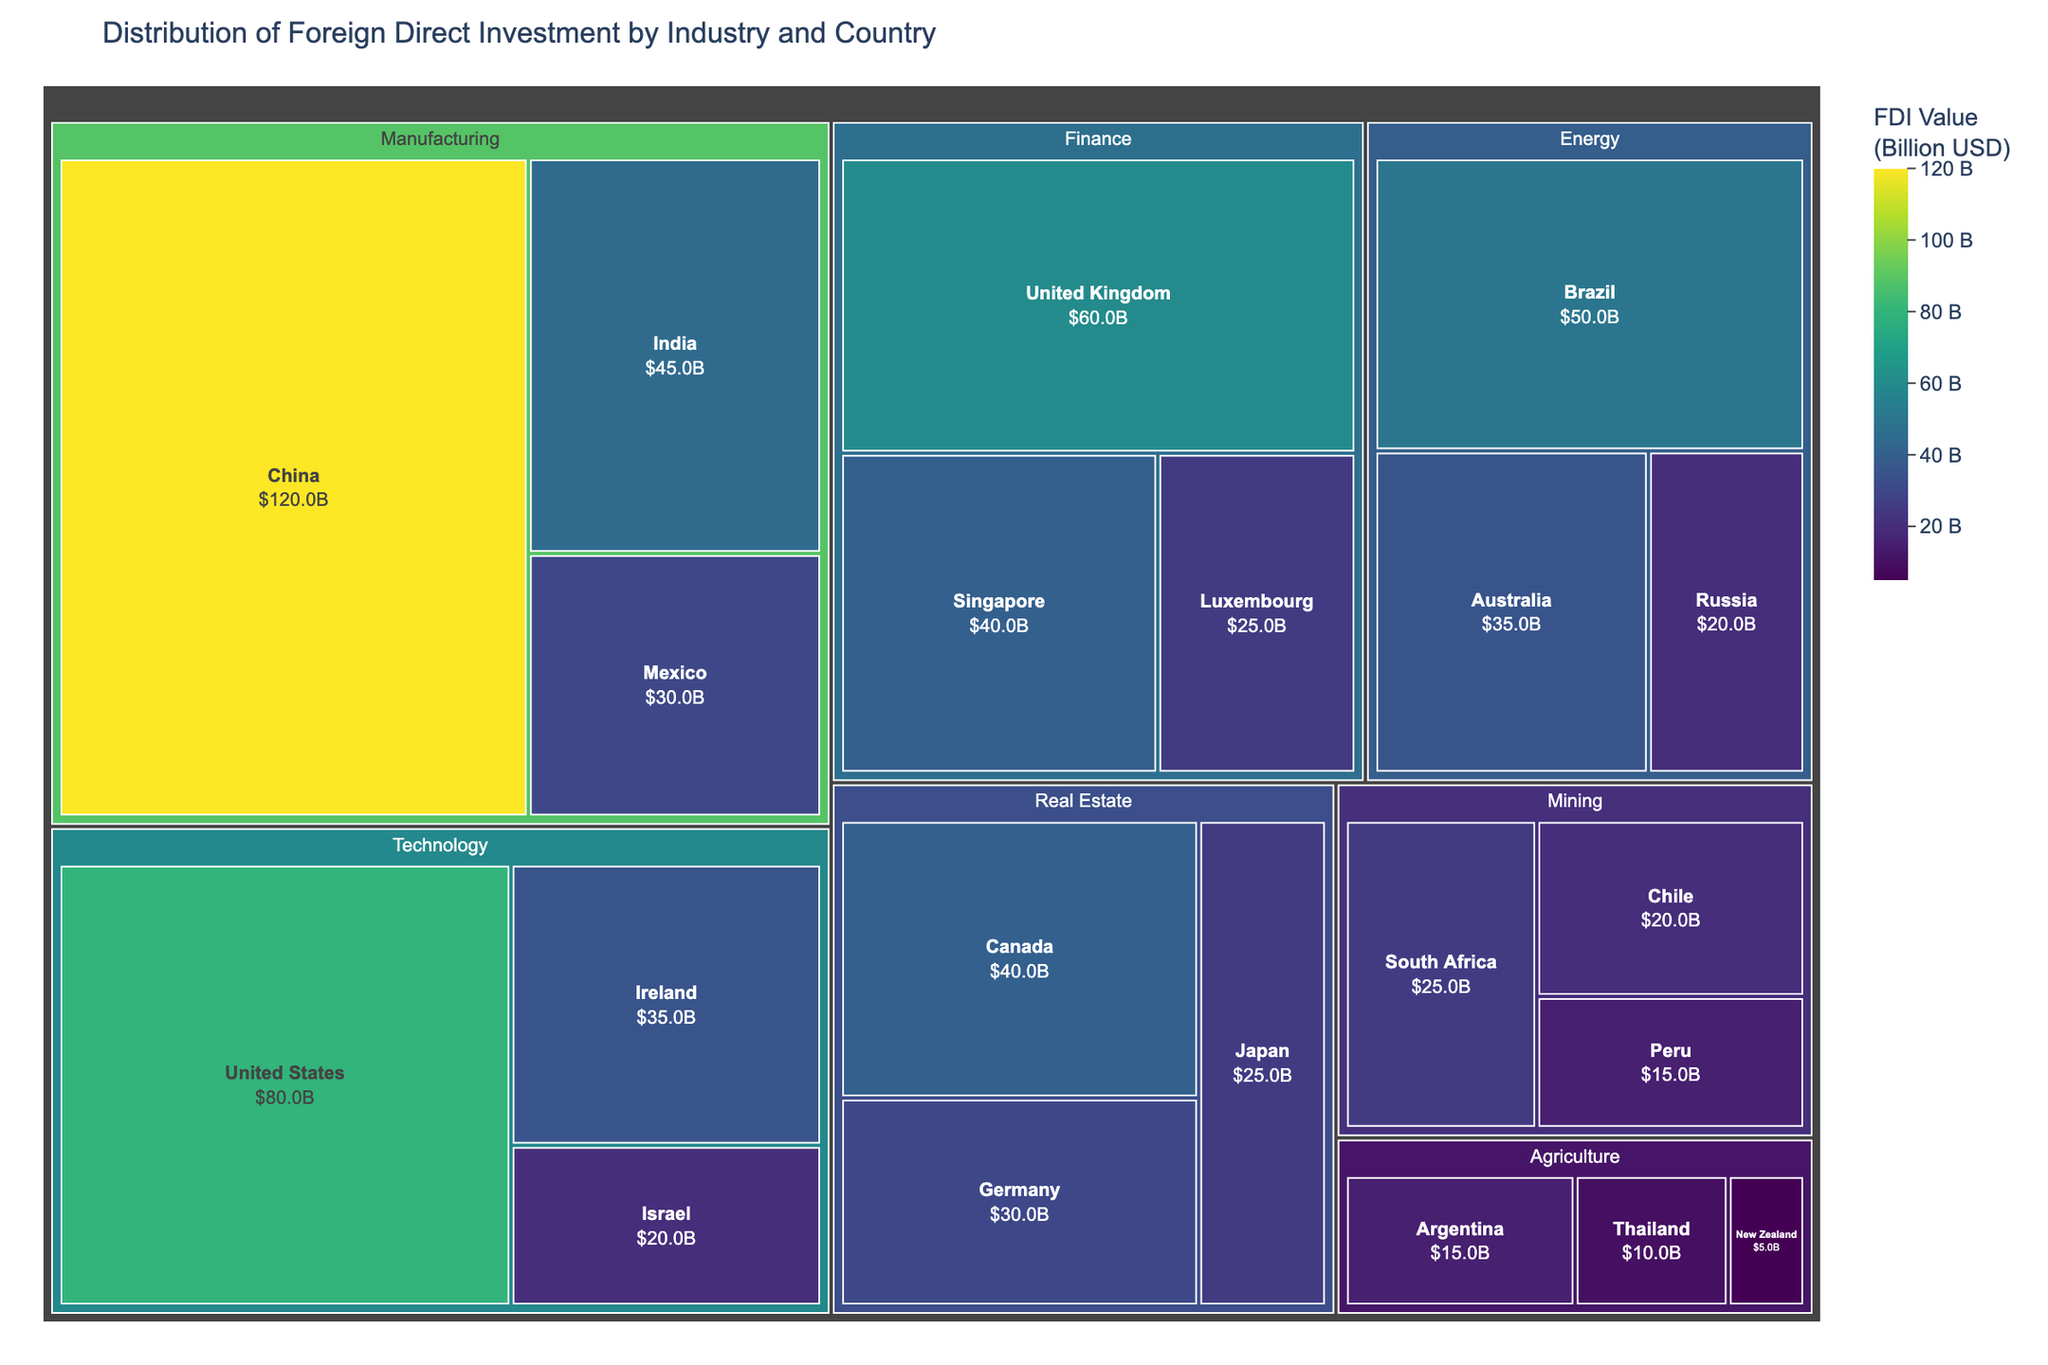What's the title of the figure? The title of the figure is usually displayed prominently at the top. In this case, it reads "Distribution of Foreign Direct Investment by Industry and Country".
Answer: Distribution of Foreign Direct Investment by Industry and Country Which industry receives the highest FDI value, and which country within that industry receives the most? The manufacturing industry receives the highest FDI value. Within manufacturing, China receives the most with 120 billion USD. This is evident as the box representing manufacturing and China within it is the largest in terms of value.
Answer: Manufacturing, China What is the total FDI value for the Technology industry across all countries? The FDI values for the Technology industry are 80 (United States), 35 (Ireland), and 20 (Israel). Summing these, we get 80 + 35 + 20 = 135 billion USD.
Answer: 135 billion USD How does the FDI value for Finance in the UK compare to the FDI value for Finance in Singapore? The FDI value for Finance in the UK is 60 billion USD and for Singapore, it is 40 billion USD. Therefore, the UK has an FDI value of 20 billion USD more than Singapore.
Answer: 20 billion USD more Which country in the Energy sector receives the least FDI and how much do they receive? Within the Energy sector, Russia receives the least FDI with a value of 20 billion USD. This can be identified by locating the smallest box within the Energy section.
Answer: Russia, 20 billion USD What is the average FDI value across all industries? To find the average FDI value, sum all the FDI values provided and divide by the number of values. The sum is: 120 + 45 + 30 + 80 + 35 + 20 + 60 + 40 + 25 + 50 + 35 + 20 + 40 + 30 + 25 + 15 + 10 + 5 + 25 + 20 + 15 = 740 billion USD. There are 21 data points. The average is 740 / 21 ≈ 35.24 billion USD.
Answer: 35.24 billion USD What is the difference between FDI values for Real Estate in Japan and Agriculture in Argentina? The FDI value for Real Estate in Japan is 25 billion USD, and for Agriculture in Argentina, it is 15 billion USD. The difference is 25 - 15 = 10 billion USD.
Answer: 10 billion USD If you combine the FDI for Agriculture and Mining industries, which industry would have a greater total FDI, Energy or the combination? The total FDI for Agriculture is 15 + 10 + 5 = 30 billion USD. For Mining, it is 25 + 20 + 15 = 60 billion USD. Combined total for Agriculture and Mining is 30 + 60 = 90 billion USD. The total FDI for Energy is 50 + 35 + 20 = 105 billion USD. Thus, Energy has a greater total FDI than the combination of Agriculture and Mining.
Answer: Energy Which sectors receive more than 50 billion USD in total FDI value? Sectors with more than 50 billion USD in total FDI are Manufacturing (120 + 45 + 30 = 195 billion USD), Technology (80 + 35 + 20 = 135 billion USD), Finance (60 + 40 + 25 = 125 billion USD), and Energy (50 + 35 + 20 = 105 billion USD).
Answer: Manufacturing, Technology, Finance, Energy What is the FDI value of the country that receives the smallest investment, and which country is it? The smallest FDI value reported is for New Zealand in the Agriculture industry, which is 5 billion USD.
Answer: 5 billion USD, New Zealand 